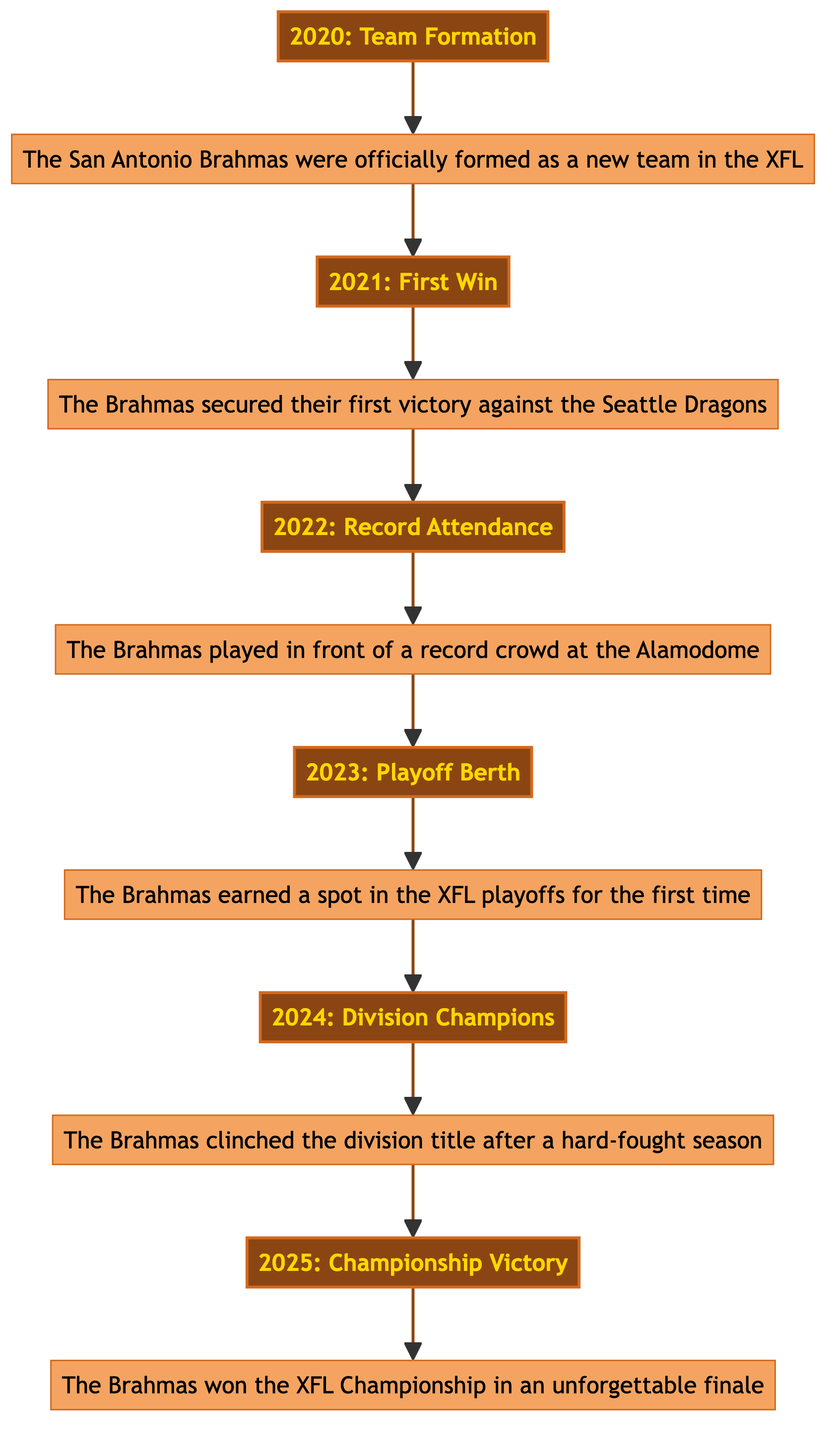What was the first milestone in the Brahmas' history? The first milestone is "Team Formation" in 2020, which establishes the team. It is the initial event in the diagram that leads to subsequent milestones.
Answer: Team Formation How many key seasons and milestones are shown in the diagram? There are six milestones depicted in the diagram, starting from 2020 to 2025. Each milestone corresponds to a significant event in the Brahmas' history, creating a total of six nodes.
Answer: Six In which year did the Brahmas secure their first victory? The diagram indicates that the first win occurred in 2021, which directly follows the team formation in the previous year.
Answer: 2021 Which milestone occurs after the "Record Attendance"? The milestone that occurs after "Record Attendance" in 2022 is "Playoff Berth" in 2023, continuing the upward progression of the team's achievements.
Answer: Playoff Berth What is the last milestone shown in the diagram? The last milestone in the flowchart for the Brahmas is the "Championship Victory," which takes place in 2025, marking the culmination of their achievements.
Answer: Championship Victory How does the "Division Champions" status relate to the "Playoff Berth"? The "Division Champions" milestone in 2024 directly follows the "Playoff Berth" in 2023, indicating a progression of success where making the playoffs is a precursor to winning the division title.
Answer: 2024 Division Champions What significant attendance milestone was achieved in 2022? The significant milestone achieved in 2022 is "Record Attendance," which highlights the support for the Brahmas at the Alamodome. This was a pivotal moment in demonstrating local community backing.
Answer: Record Attendance Is there a milestone indicating the first playoff appearance? Yes, the first playoff appearance for the Brahmas is indicated by the "Playoff Berth" milestone in 2023, marking an important development for the team's competitive standing.
Answer: Playoff Berth What was a notable achievement for the team in 2025? The notable achievement for the team in 2025 was winning the "XFL Championship," which solidifies their legacy in American football history. This victory represents the pinnacle of their journey in the diagram.
Answer: Championship Victory 